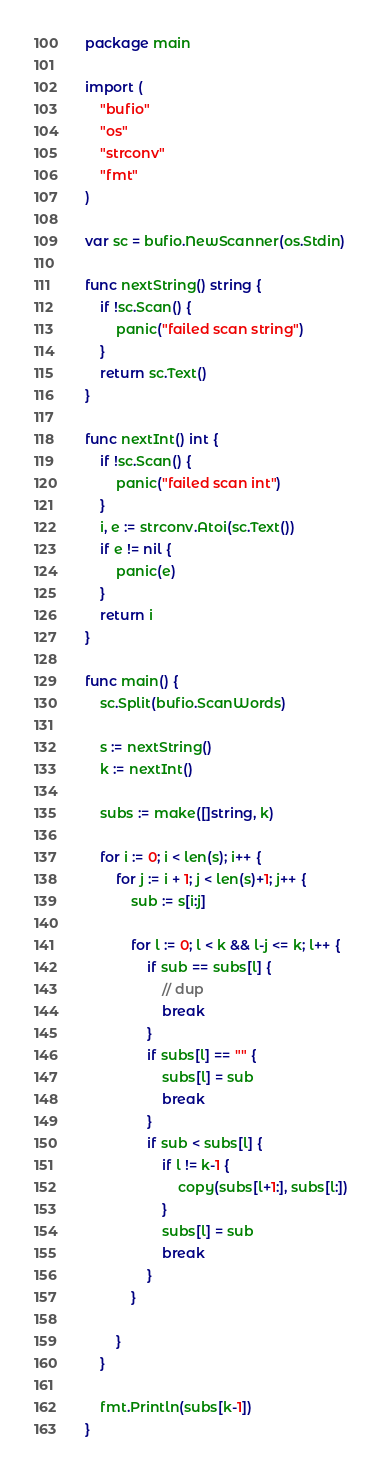<code> <loc_0><loc_0><loc_500><loc_500><_Go_>package main

import (
	"bufio"
	"os"
	"strconv"
	"fmt"
)

var sc = bufio.NewScanner(os.Stdin)

func nextString() string {
	if !sc.Scan() {
		panic("failed scan string")
	}
	return sc.Text()
}

func nextInt() int {
	if !sc.Scan() {
		panic("failed scan int")
	}
	i, e := strconv.Atoi(sc.Text())
	if e != nil {
		panic(e)
	}
	return i
}

func main() {
	sc.Split(bufio.ScanWords)

	s := nextString()
	k := nextInt()

	subs := make([]string, k)

	for i := 0; i < len(s); i++ {
		for j := i + 1; j < len(s)+1; j++ {
			sub := s[i:j]

			for l := 0; l < k && l-j <= k; l++ {
				if sub == subs[l] {
					// dup
					break
				}
				if subs[l] == "" {
					subs[l] = sub
					break
				}
				if sub < subs[l] {
					if l != k-1 {
						copy(subs[l+1:], subs[l:])
					}
					subs[l] = sub
					break
				}
			}

		}
	}

	fmt.Println(subs[k-1])
}
</code> 